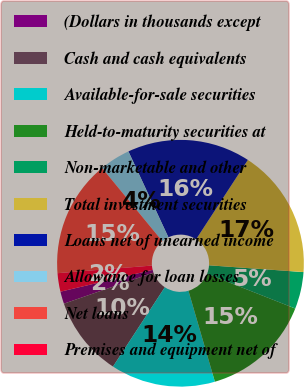<chart> <loc_0><loc_0><loc_500><loc_500><pie_chart><fcel>(Dollars in thousands except<fcel>Cash and cash equivalents<fcel>Available-for-sale securities<fcel>Held-to-maturity securities at<fcel>Non-marketable and other<fcel>Total investment securities<fcel>Loans net of unearned income<fcel>Allowance for loan losses<fcel>Net loans<fcel>Premises and equipment net of<nl><fcel>1.61%<fcel>10.48%<fcel>13.71%<fcel>14.52%<fcel>4.84%<fcel>16.94%<fcel>16.13%<fcel>4.03%<fcel>15.32%<fcel>2.42%<nl></chart> 